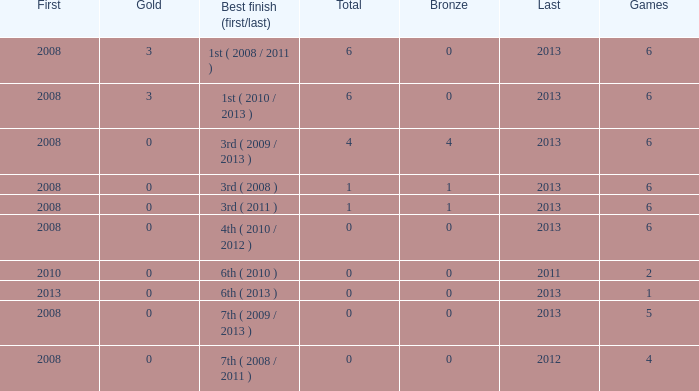What is the latest first year with 0 total medals and over 0 golds? 2008.0. 